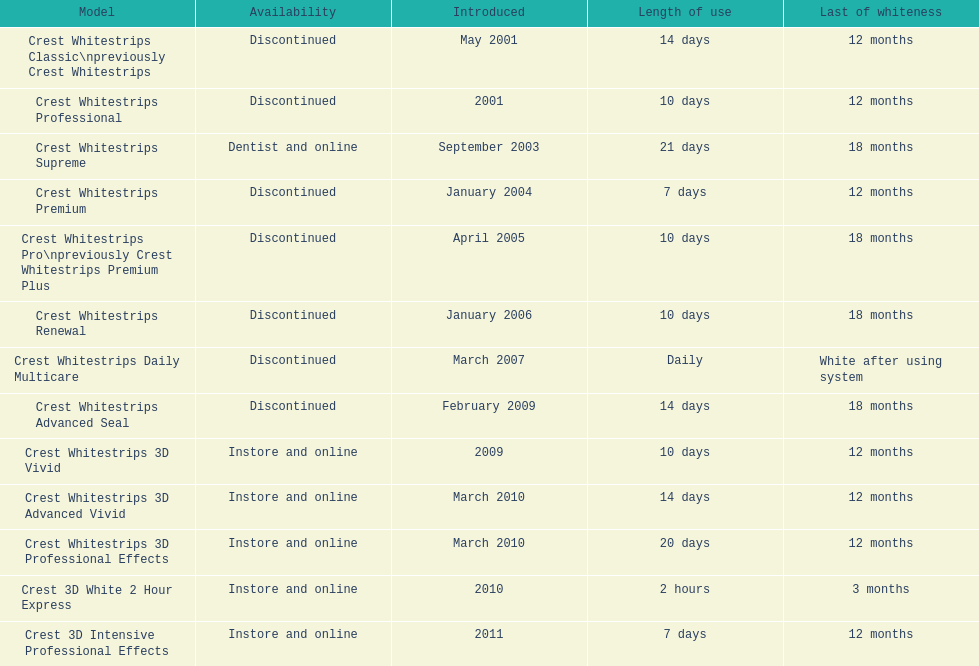Which product has a longer duration of use, crest whitestrips classic or crest whitestrips 3d vivid? Crest Whitestrips Classic. 